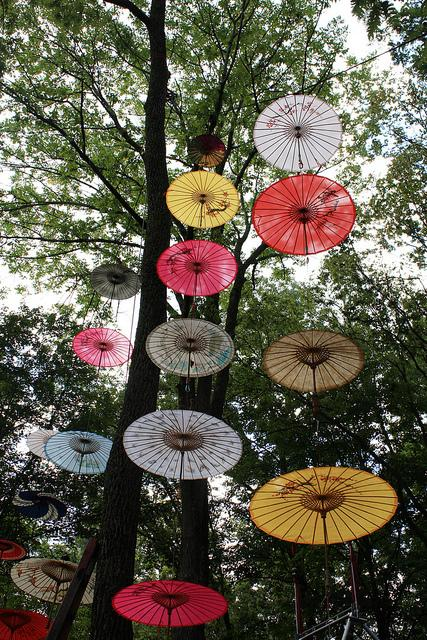What is near the colorful items? tree 